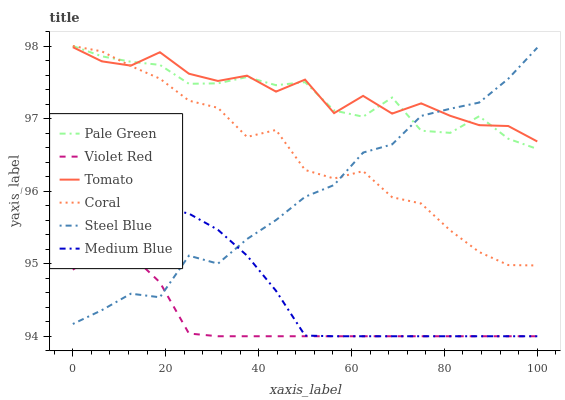Does Violet Red have the minimum area under the curve?
Answer yes or no. Yes. Does Tomato have the maximum area under the curve?
Answer yes or no. Yes. Does Coral have the minimum area under the curve?
Answer yes or no. No. Does Coral have the maximum area under the curve?
Answer yes or no. No. Is Medium Blue the smoothest?
Answer yes or no. Yes. Is Tomato the roughest?
Answer yes or no. Yes. Is Violet Red the smoothest?
Answer yes or no. No. Is Violet Red the roughest?
Answer yes or no. No. Does Violet Red have the lowest value?
Answer yes or no. Yes. Does Coral have the lowest value?
Answer yes or no. No. Does Pale Green have the highest value?
Answer yes or no. Yes. Does Violet Red have the highest value?
Answer yes or no. No. Is Violet Red less than Coral?
Answer yes or no. Yes. Is Tomato greater than Violet Red?
Answer yes or no. Yes. Does Violet Red intersect Steel Blue?
Answer yes or no. Yes. Is Violet Red less than Steel Blue?
Answer yes or no. No. Is Violet Red greater than Steel Blue?
Answer yes or no. No. Does Violet Red intersect Coral?
Answer yes or no. No. 